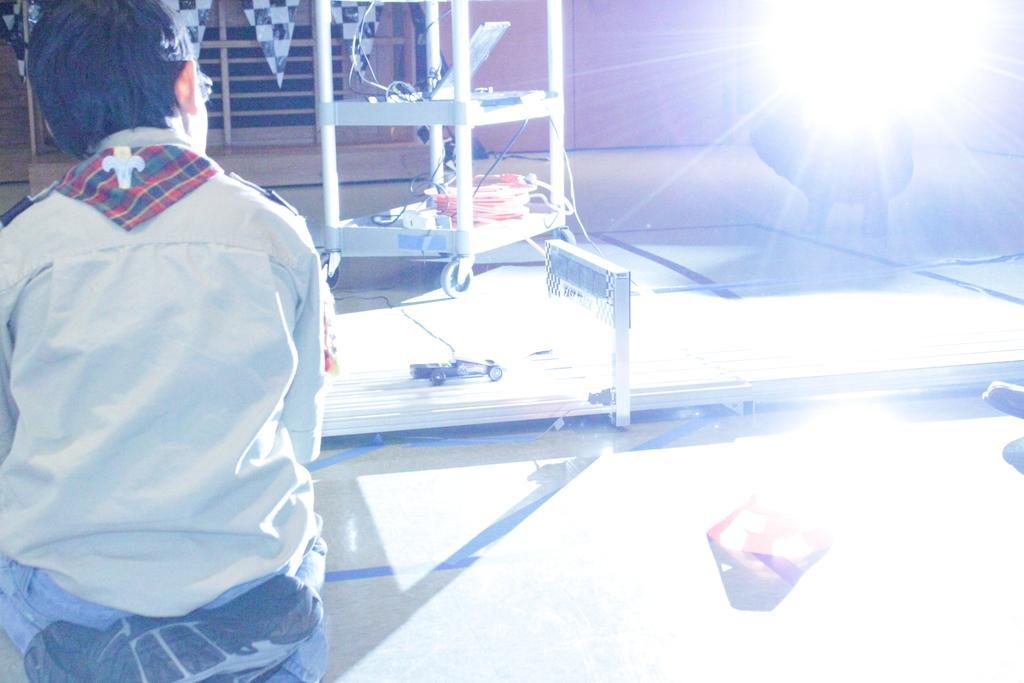How would you summarize this image in a sentence or two? In the picture we can see a boy and beside him we can see a table tennis table and on it we can see a toy car and behind it, we can see the table with wheels and some things are placed in it and beside it we can see the light focus. 